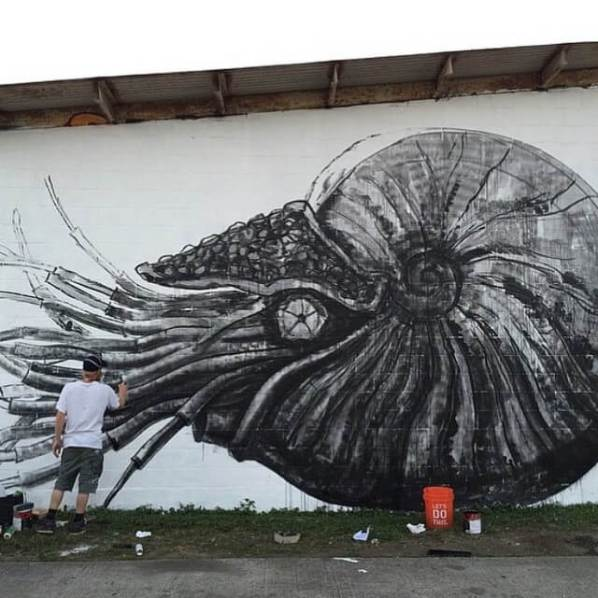Considering the items on the ground, what can we infer about the muralist's preparation and painting process? Based on the items on the ground, it is apparent that the muralist is meticulously prepared for a detailed and layered painting process. The multiple paint cans hint at the use of various shades and tones, likely employed to achieve depth, contrast, and intricate details within the mural. The presence of a paint tray suggests that the artist utilizes a roller for efficiently covering large areas with consistent strokes. Additionally, the smaller items, such as brushes, indicate that the artist pays attention to finer details, ensuring precision in their work. The inclusion of a single-step platform demonstrates that the artist focuses on sections of the mural that are within reachable heights, possibly suggesting a strategic division of the mural painting process into manageable sections. Overall, the arrangement of supplies conveys a well-organized and thoughtful approach to creating the mural, combining broad strokes with meticulous detailing. 